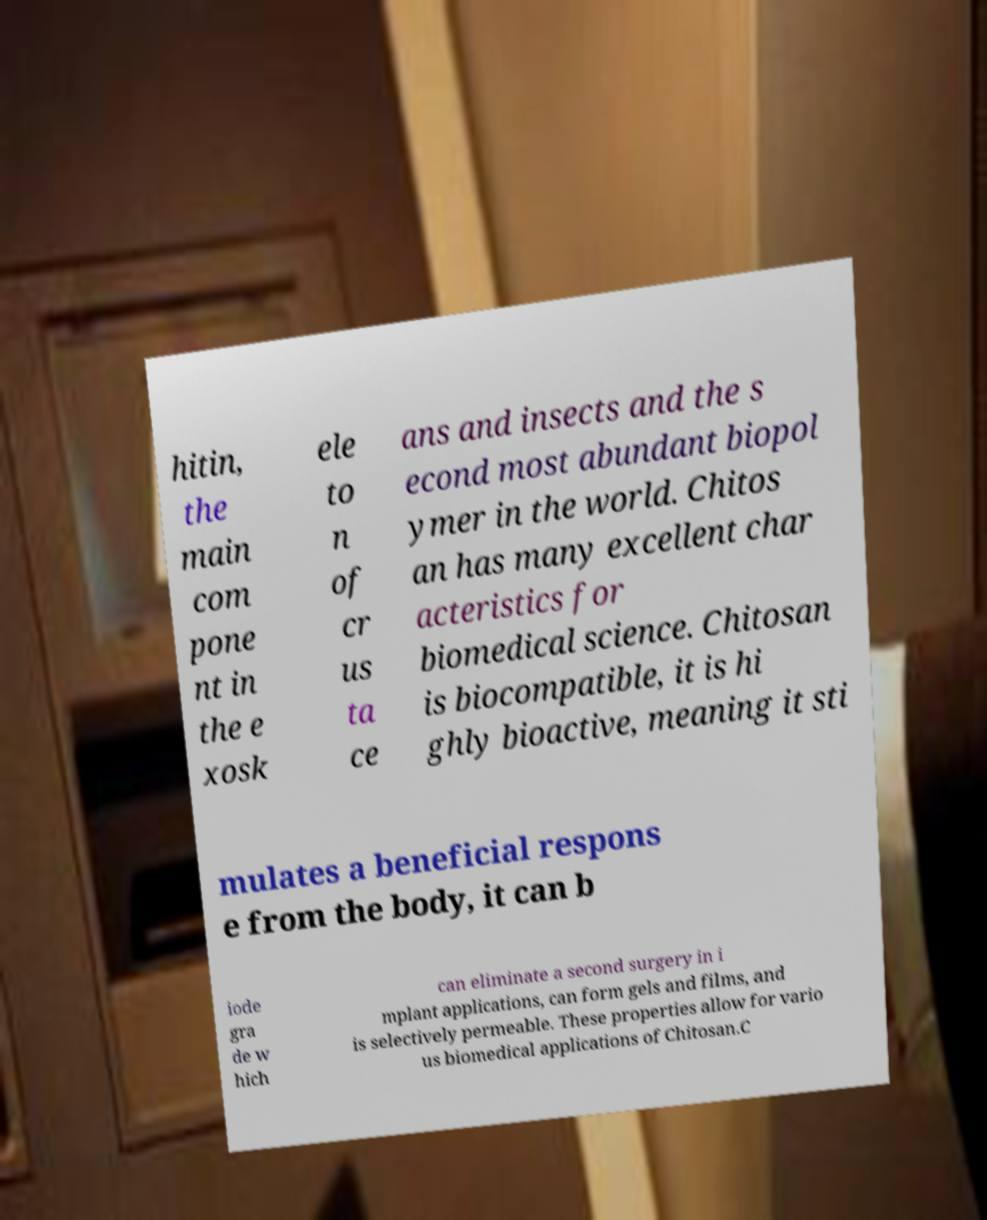Can you accurately transcribe the text from the provided image for me? hitin, the main com pone nt in the e xosk ele to n of cr us ta ce ans and insects and the s econd most abundant biopol ymer in the world. Chitos an has many excellent char acteristics for biomedical science. Chitosan is biocompatible, it is hi ghly bioactive, meaning it sti mulates a beneficial respons e from the body, it can b iode gra de w hich can eliminate a second surgery in i mplant applications, can form gels and films, and is selectively permeable. These properties allow for vario us biomedical applications of Chitosan.C 